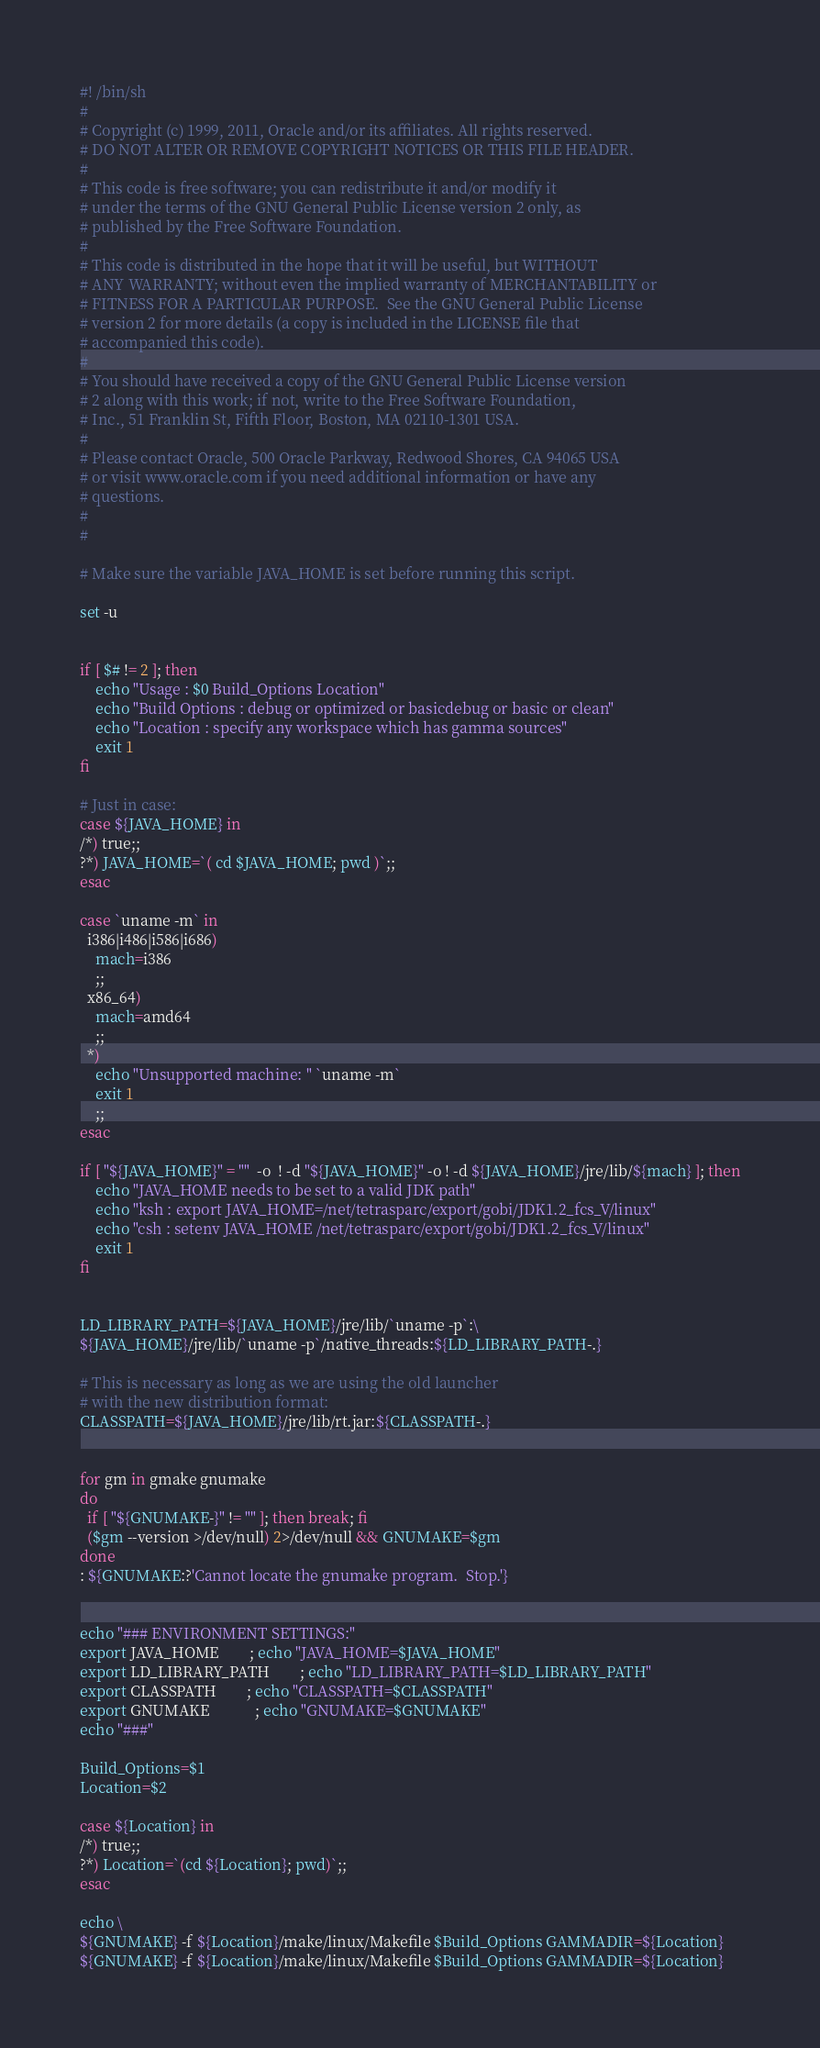<code> <loc_0><loc_0><loc_500><loc_500><_Bash_>#! /bin/sh
#
# Copyright (c) 1999, 2011, Oracle and/or its affiliates. All rights reserved.
# DO NOT ALTER OR REMOVE COPYRIGHT NOTICES OR THIS FILE HEADER.
#
# This code is free software; you can redistribute it and/or modify it
# under the terms of the GNU General Public License version 2 only, as
# published by the Free Software Foundation.
#
# This code is distributed in the hope that it will be useful, but WITHOUT
# ANY WARRANTY; without even the implied warranty of MERCHANTABILITY or
# FITNESS FOR A PARTICULAR PURPOSE.  See the GNU General Public License
# version 2 for more details (a copy is included in the LICENSE file that
# accompanied this code).
#
# You should have received a copy of the GNU General Public License version
# 2 along with this work; if not, write to the Free Software Foundation,
# Inc., 51 Franklin St, Fifth Floor, Boston, MA 02110-1301 USA.
#
# Please contact Oracle, 500 Oracle Parkway, Redwood Shores, CA 94065 USA
# or visit www.oracle.com if you need additional information or have any
# questions.
#  
#

# Make sure the variable JAVA_HOME is set before running this script.

set -u


if [ $# != 2 ]; then 
    echo "Usage : $0 Build_Options Location"
    echo "Build Options : debug or optimized or basicdebug or basic or clean"
    echo "Location : specify any workspace which has gamma sources"
    exit 1
fi

# Just in case:
case ${JAVA_HOME} in
/*) true;;
?*) JAVA_HOME=`( cd $JAVA_HOME; pwd )`;;
esac

case `uname -m` in
  i386|i486|i586|i686)
    mach=i386
    ;;
  x86_64)
    mach=amd64
    ;;
  *)
    echo "Unsupported machine: " `uname -m`
    exit 1
    ;;
esac

if [ "${JAVA_HOME}" = ""  -o  ! -d "${JAVA_HOME}" -o ! -d ${JAVA_HOME}/jre/lib/${mach} ]; then
    echo "JAVA_HOME needs to be set to a valid JDK path"
    echo "ksh : export JAVA_HOME=/net/tetrasparc/export/gobi/JDK1.2_fcs_V/linux"
    echo "csh : setenv JAVA_HOME /net/tetrasparc/export/gobi/JDK1.2_fcs_V/linux"
    exit 1
fi


LD_LIBRARY_PATH=${JAVA_HOME}/jre/lib/`uname -p`:\
${JAVA_HOME}/jre/lib/`uname -p`/native_threads:${LD_LIBRARY_PATH-.}

# This is necessary as long as we are using the old launcher
# with the new distribution format:
CLASSPATH=${JAVA_HOME}/jre/lib/rt.jar:${CLASSPATH-.}


for gm in gmake gnumake
do
  if [ "${GNUMAKE-}" != "" ]; then break; fi
  ($gm --version >/dev/null) 2>/dev/null && GNUMAKE=$gm
done
: ${GNUMAKE:?'Cannot locate the gnumake program.  Stop.'}


echo "### ENVIRONMENT SETTINGS:"
export JAVA_HOME		; echo "JAVA_HOME=$JAVA_HOME"
export LD_LIBRARY_PATH		; echo "LD_LIBRARY_PATH=$LD_LIBRARY_PATH"
export CLASSPATH		; echo "CLASSPATH=$CLASSPATH"
export GNUMAKE			; echo "GNUMAKE=$GNUMAKE"
echo "###"

Build_Options=$1
Location=$2

case ${Location} in
/*) true;;
?*) Location=`(cd ${Location}; pwd)`;;
esac

echo \
${GNUMAKE} -f ${Location}/make/linux/Makefile $Build_Options GAMMADIR=${Location}
${GNUMAKE} -f ${Location}/make/linux/Makefile $Build_Options GAMMADIR=${Location}
</code> 